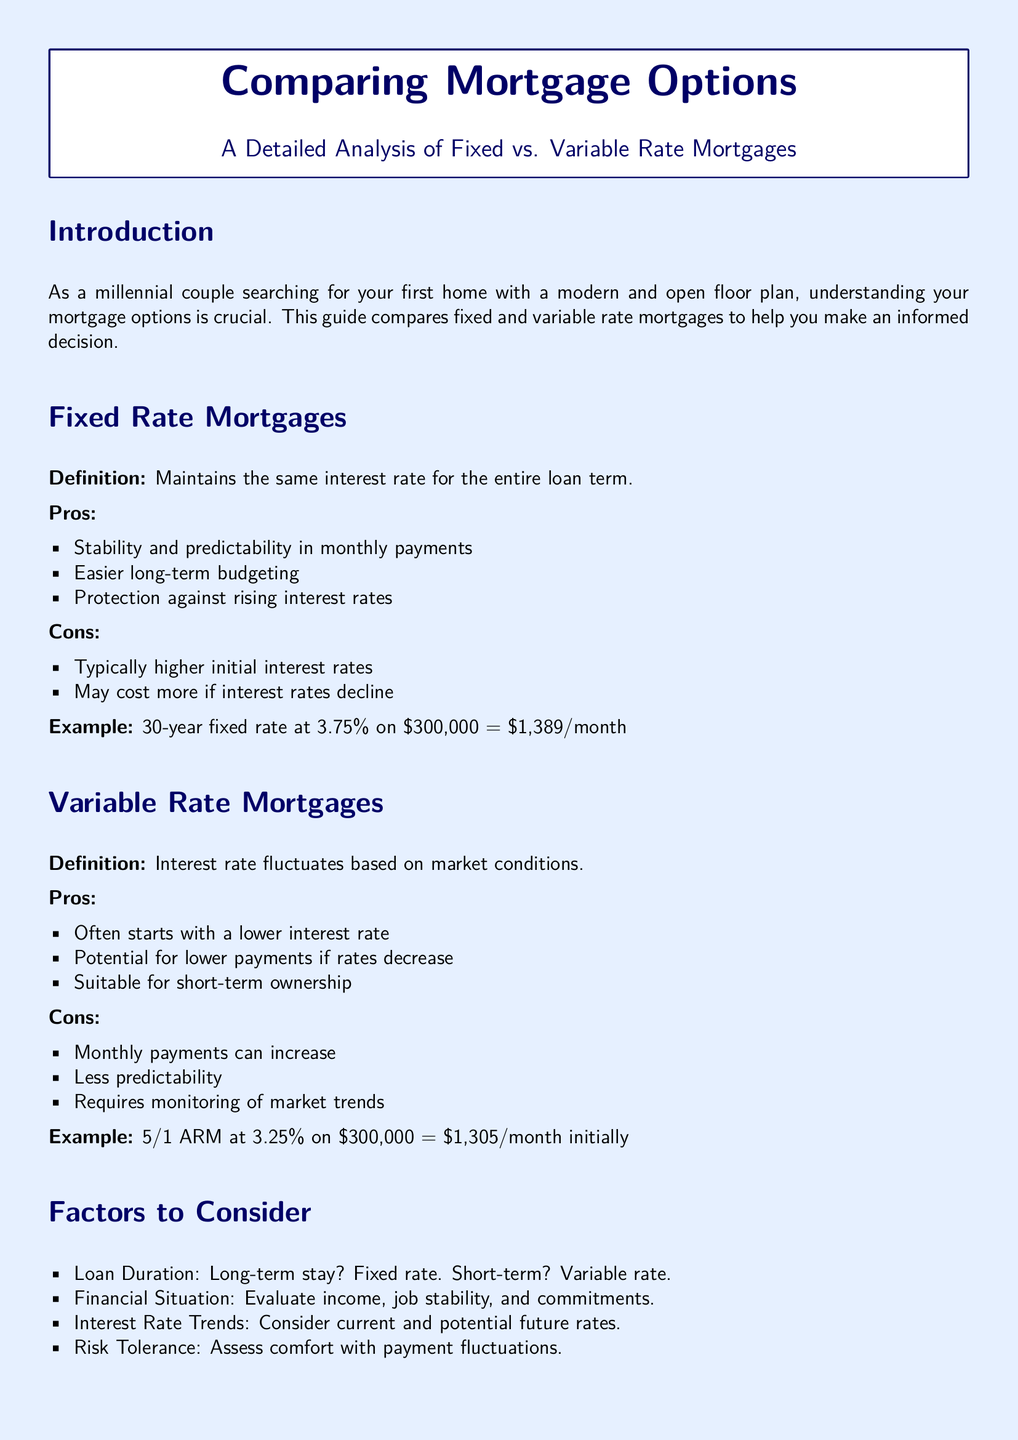what is a fixed rate mortgage? A fixed rate mortgage maintains the same interest rate for the entire loan term.
Answer: maintains the same interest rate for the entire loan term what is the typical initial interest rate for a 5/1 ARM? The document states that a 5/1 ARM starts at an interest rate of 3.25%.
Answer: 3.25% what is the example monthly payment for a 30-year fixed rate? The example given for a 30-year fixed rate mortgage at 3.75% on $300,000 is $1,389/month.
Answer: $1,389/month what are the cons of a variable rate mortgage? The document lists increased monthly payments, less predictability, and the need for monitoring market trends as cons.
Answer: increased monthly payments, less predictability, monitoring market trends what is a key factor to consider for loan duration? The document states that a long-term stay should consider a fixed rate and a short-term stay should consider a variable rate.
Answer: long-term stay: fixed rate; short-term: variable rate how does the stability of monthly payments compare between fixed and variable rate mortgages? Fixed rate mortgages offer stability and predictability while variable rate mortgages can fluctuate.
Answer: Fixed: stability; Variable: fluctuations what are two recommended resource websites mentioned? The document suggests Bankrate and NerdWallet as resources.
Answer: Bankrate, NerdWallet what is one advantage of a fixed rate mortgage? One advantage is stability and predictability in monthly payments.
Answer: stability and predictability in monthly payments what is a potential benefit of a variable rate mortgage in terms of interest rate? A variable rate mortgage often starts with a lower interest rate compared to a fixed rate.
Answer: starts with a lower interest rate 